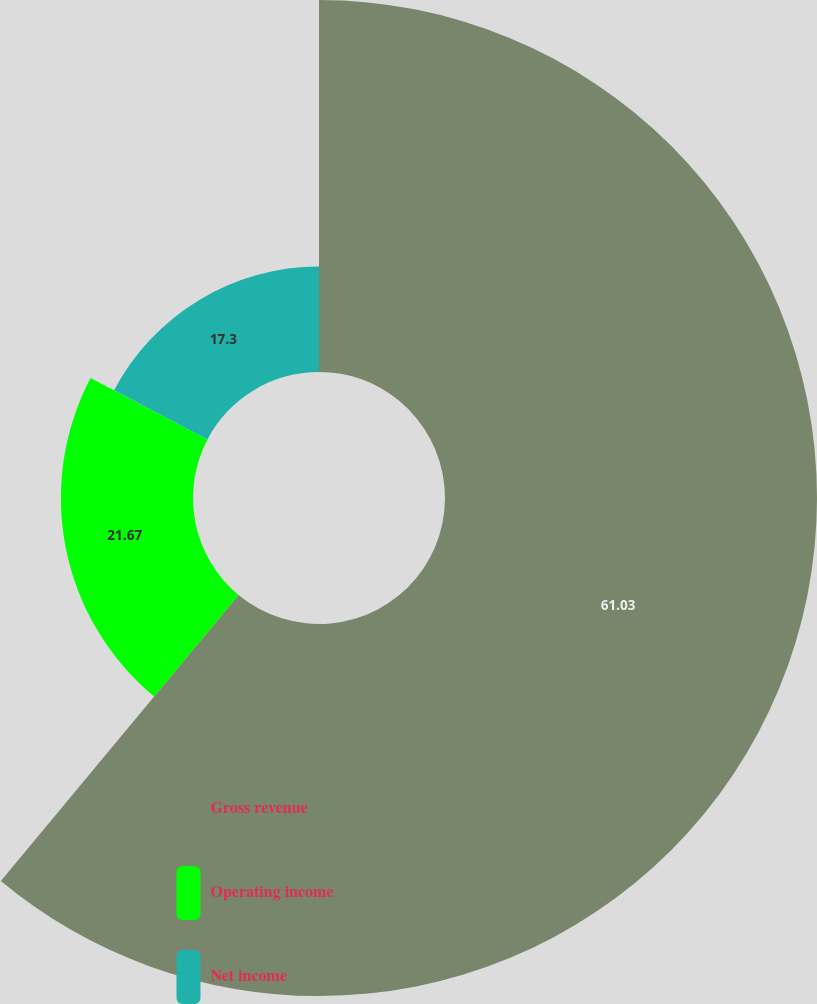<chart> <loc_0><loc_0><loc_500><loc_500><pie_chart><fcel>Gross revenue<fcel>Operating income<fcel>Net income<nl><fcel>61.03%<fcel>21.67%<fcel>17.3%<nl></chart> 